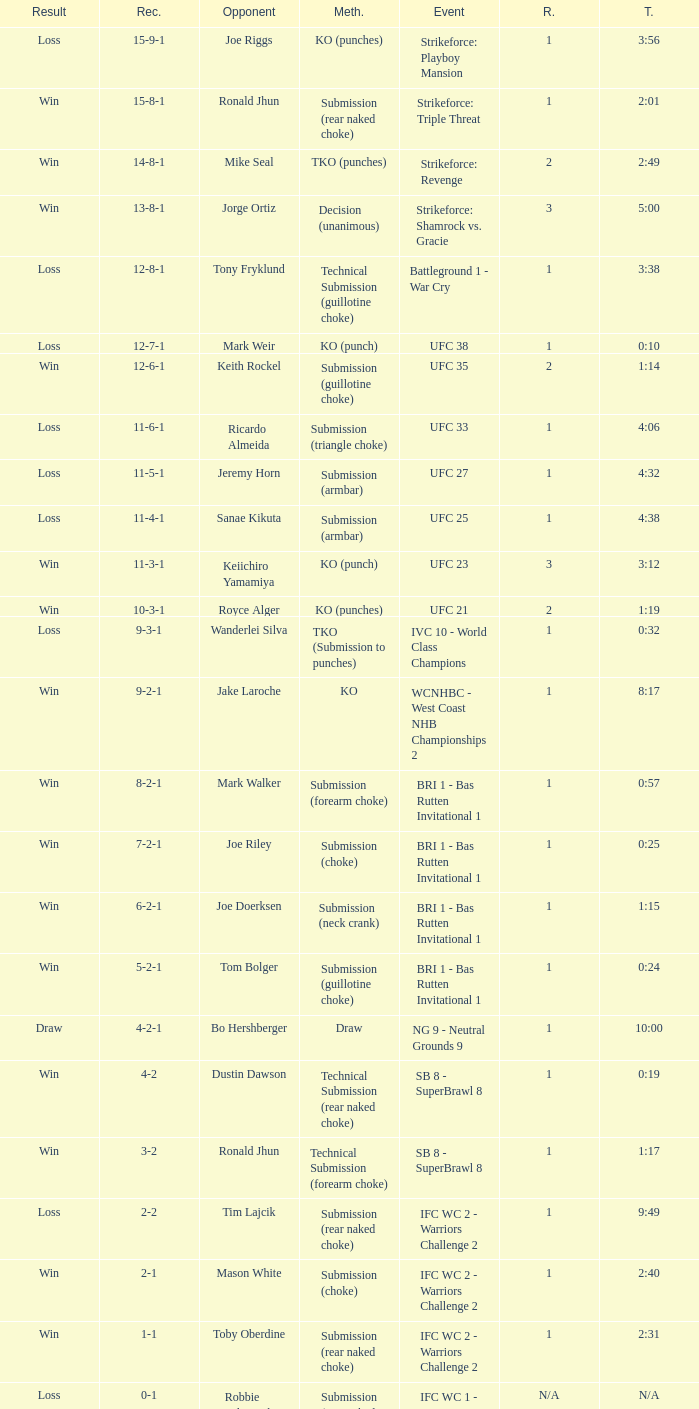What is the performance record at the ufc 27 event? 11-5-1. 